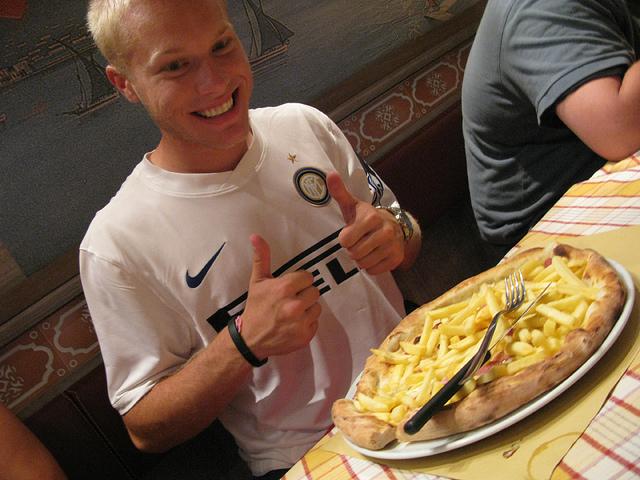Where is the Nike logo?
Answer briefly. Shirt. Is the man sad?
Be succinct. No. What is the food?
Give a very brief answer. Pizza. What is the man pointing to?
Write a very short answer. Himself. 